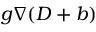Convert formula to latex. <formula><loc_0><loc_0><loc_500><loc_500>g \nabla ( D + b )</formula> 